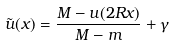Convert formula to latex. <formula><loc_0><loc_0><loc_500><loc_500>\tilde { u } ( x ) = \frac { M - u ( 2 R x ) } { M - m } + \gamma</formula> 